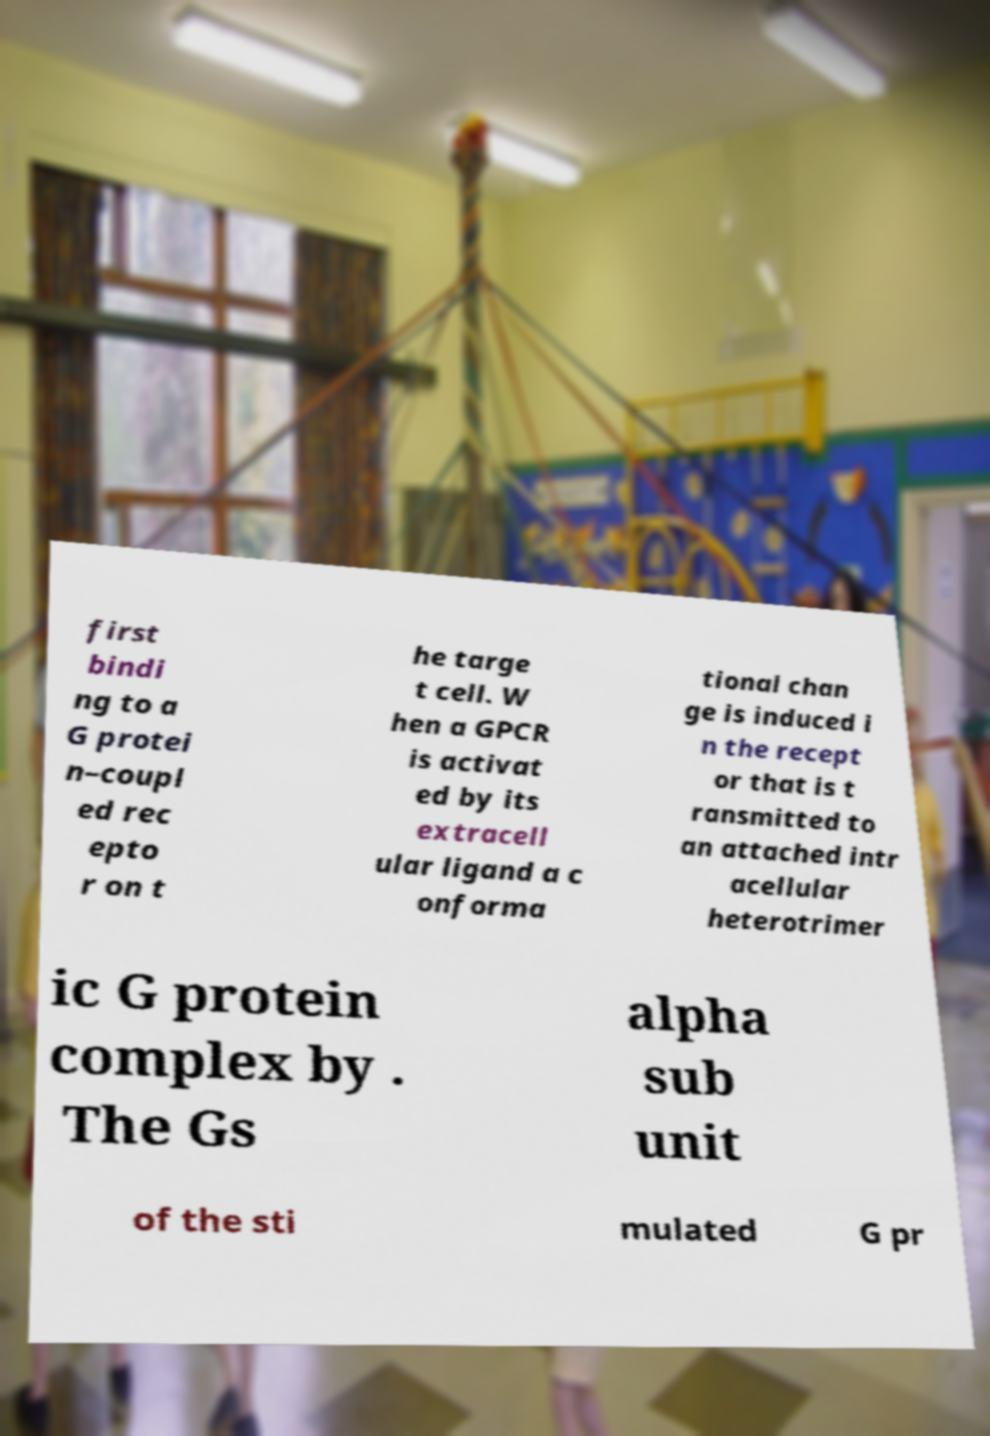Could you extract and type out the text from this image? first bindi ng to a G protei n–coupl ed rec epto r on t he targe t cell. W hen a GPCR is activat ed by its extracell ular ligand a c onforma tional chan ge is induced i n the recept or that is t ransmitted to an attached intr acellular heterotrimer ic G protein complex by . The Gs alpha sub unit of the sti mulated G pr 